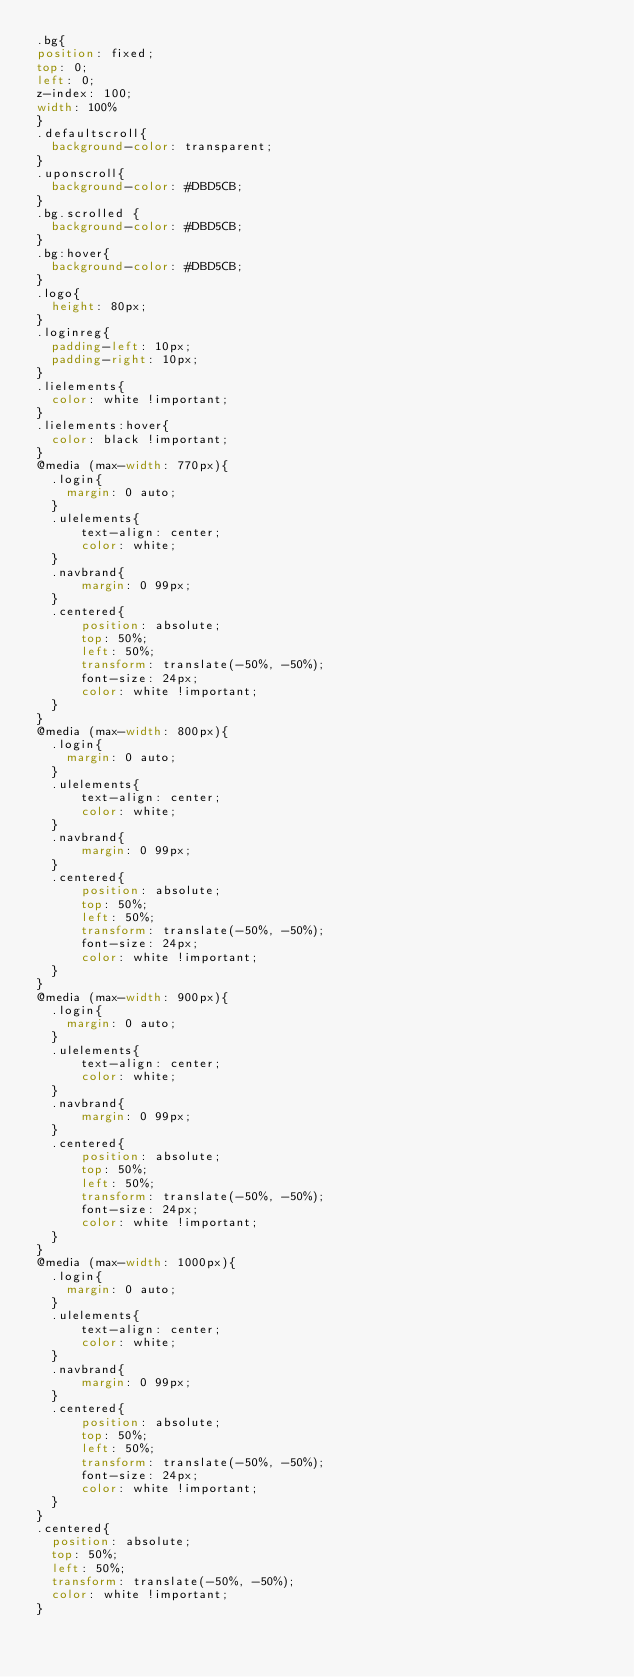<code> <loc_0><loc_0><loc_500><loc_500><_CSS_>.bg{
position: fixed;
top: 0;
left: 0;
z-index: 100;
width: 100% 
}
.defaultscroll{
  background-color: transparent;
}
.uponscroll{
  background-color: #DBD5CB;
}
.bg.scrolled {
  background-color: #DBD5CB;
}
.bg:hover{
  background-color: #DBD5CB;
}
.logo{
  height: 80px;
}
.loginreg{
  padding-left: 10px;
  padding-right: 10px;
}
.lielements{
  color: white !important;
}
.lielements:hover{
  color: black !important;
}
@media (max-width: 770px){
  .login{
    margin: 0 auto;
  }
  .ulelements{
      text-align: center;
      color: white;
  }
  .navbrand{
      margin: 0 99px;
  }
  .centered{
      position: absolute;
      top: 50%;
      left: 50%;
      transform: translate(-50%, -50%);
      font-size: 24px;
      color: white !important;
  }
}
@media (max-width: 800px){
  .login{
    margin: 0 auto;
  }
  .ulelements{
      text-align: center;
      color: white;
  }
  .navbrand{
      margin: 0 99px;
  }
  .centered{
      position: absolute;
      top: 50%;
      left: 50%;
      transform: translate(-50%, -50%);
      font-size: 24px;
      color: white !important;
  }
}
@media (max-width: 900px){
  .login{
    margin: 0 auto;
  }
  .ulelements{
      text-align: center;
      color: white;
  }
  .navbrand{
      margin: 0 99px;
  }
  .centered{
      position: absolute;
      top: 50%;
      left: 50%;
      transform: translate(-50%, -50%);
      font-size: 24px;
      color: white !important;
  }
}
@media (max-width: 1000px){
  .login{
    margin: 0 auto;
  }
  .ulelements{
      text-align: center;
      color: white;
  }
  .navbrand{
      margin: 0 99px;
  }
  .centered{
      position: absolute;
      top: 50%;
      left: 50%;
      transform: translate(-50%, -50%);
      font-size: 24px;
      color: white !important;
  }
}
.centered{
  position: absolute;
  top: 50%;
  left: 50%;
  transform: translate(-50%, -50%);
  color: white !important;
}</code> 